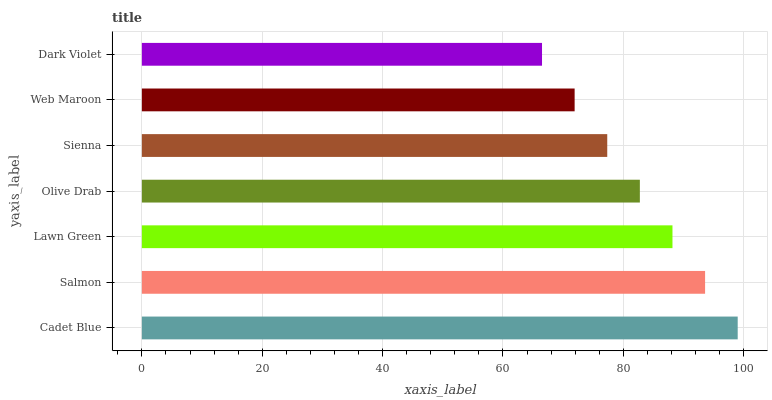Is Dark Violet the minimum?
Answer yes or no. Yes. Is Cadet Blue the maximum?
Answer yes or no. Yes. Is Salmon the minimum?
Answer yes or no. No. Is Salmon the maximum?
Answer yes or no. No. Is Cadet Blue greater than Salmon?
Answer yes or no. Yes. Is Salmon less than Cadet Blue?
Answer yes or no. Yes. Is Salmon greater than Cadet Blue?
Answer yes or no. No. Is Cadet Blue less than Salmon?
Answer yes or no. No. Is Olive Drab the high median?
Answer yes or no. Yes. Is Olive Drab the low median?
Answer yes or no. Yes. Is Sienna the high median?
Answer yes or no. No. Is Lawn Green the low median?
Answer yes or no. No. 